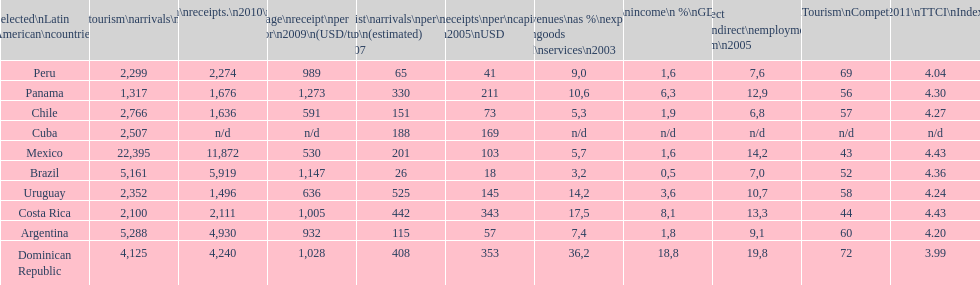What is the last country listed on this chart? Uruguay. 